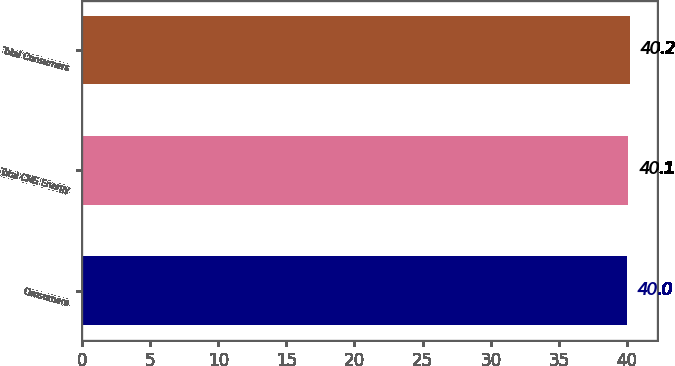<chart> <loc_0><loc_0><loc_500><loc_500><bar_chart><fcel>Consumers<fcel>Total CMS Energy<fcel>Total Consumers<nl><fcel>40<fcel>40.1<fcel>40.2<nl></chart> 